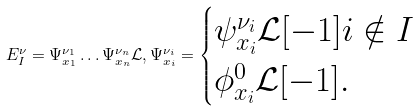Convert formula to latex. <formula><loc_0><loc_0><loc_500><loc_500>E _ { I } ^ { \nu } = \Psi _ { x _ { 1 } } ^ { \nu _ { 1 } } \dots \Psi _ { x _ { n } } ^ { \nu _ { n } } \mathcal { L } , \Psi _ { x _ { i } } ^ { \nu _ { i } } = \begin{cases} \psi _ { x _ { i } } ^ { \nu _ { i } } \mathcal { L } [ - 1 ] i \notin I \\ \phi _ { x _ { i } } ^ { 0 } \mathcal { L } [ - 1 ] . \end{cases}</formula> 